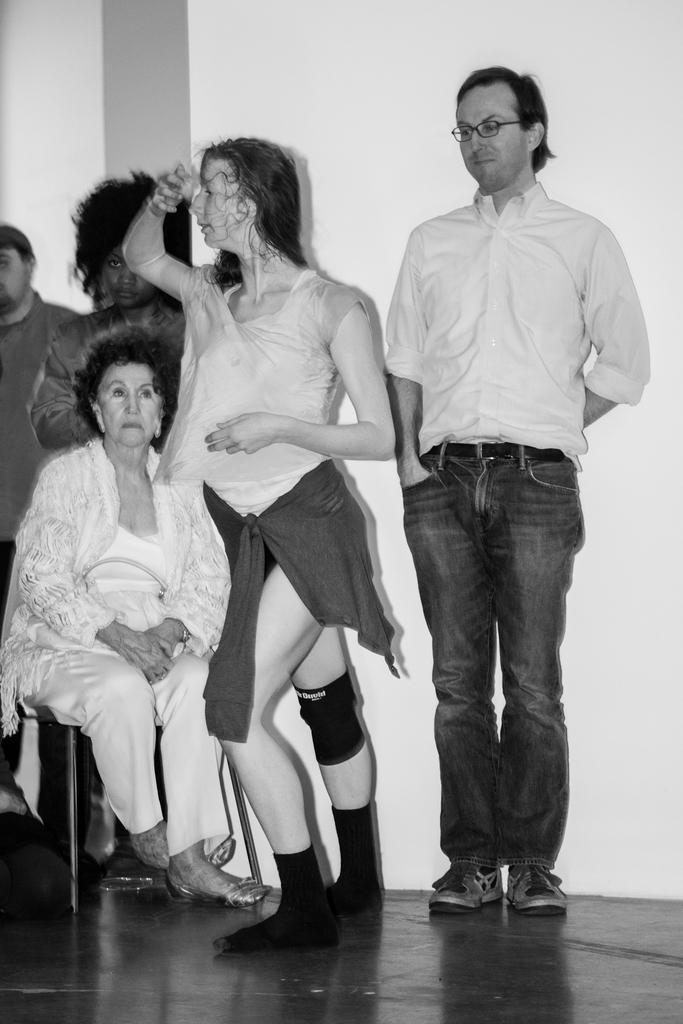Please provide a concise description of this image. This is a black and white image. On the left side there is a woman sitting on a chair which is placed on the floor and there are four persons standing. In the background there is a wall. 